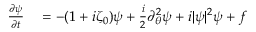<formula> <loc_0><loc_0><loc_500><loc_500>\begin{array} { r l } { \frac { \partial \psi } { \partial t } } & = - ( 1 + i \zeta _ { 0 } ) \psi + \frac { i } { 2 } \partial _ { \theta } ^ { 2 } \psi + i | \psi | ^ { 2 } \psi + f } \end{array}</formula> 